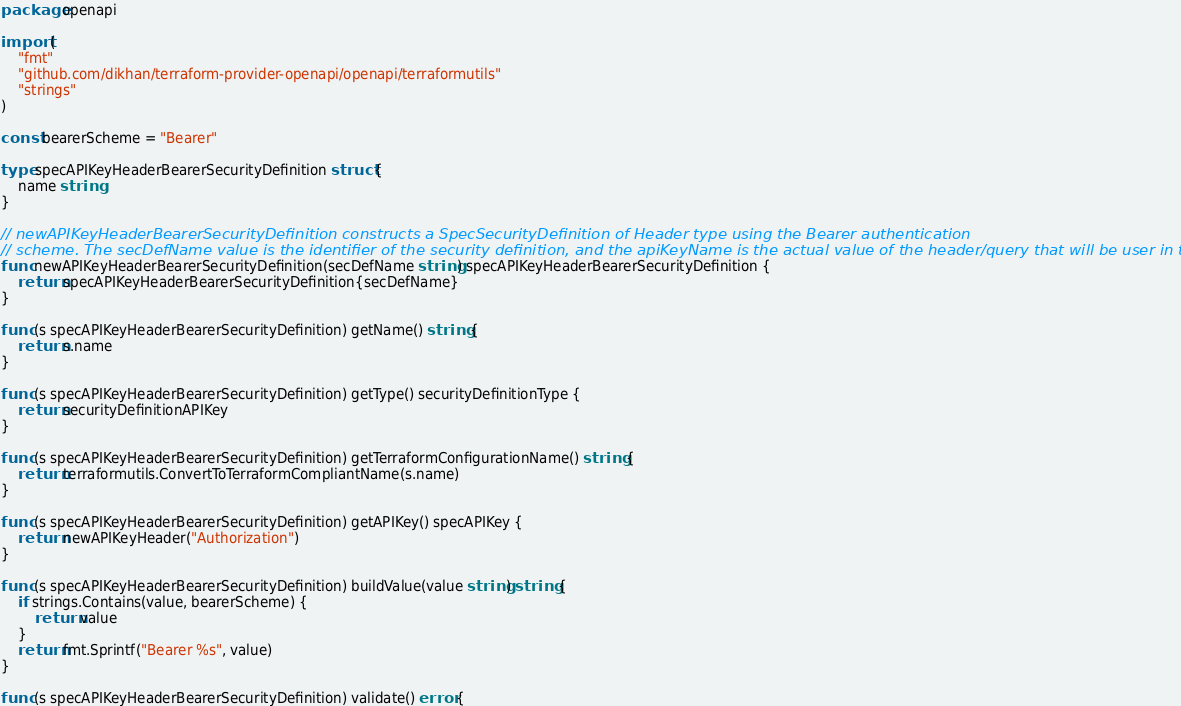Convert code to text. <code><loc_0><loc_0><loc_500><loc_500><_Go_>package openapi

import (
	"fmt"
	"github.com/dikhan/terraform-provider-openapi/openapi/terraformutils"
	"strings"
)

const bearerScheme = "Bearer"

type specAPIKeyHeaderBearerSecurityDefinition struct {
	name string
}

// newAPIKeyHeaderBearerSecurityDefinition constructs a SpecSecurityDefinition of Header type using the Bearer authentication
// scheme. The secDefName value is the identifier of the security definition, and the apiKeyName is the actual value of the header/query that will be user in the HTTP request.
func newAPIKeyHeaderBearerSecurityDefinition(secDefName string) specAPIKeyHeaderBearerSecurityDefinition {
	return specAPIKeyHeaderBearerSecurityDefinition{secDefName}
}

func (s specAPIKeyHeaderBearerSecurityDefinition) getName() string {
	return s.name
}

func (s specAPIKeyHeaderBearerSecurityDefinition) getType() securityDefinitionType {
	return securityDefinitionAPIKey
}

func (s specAPIKeyHeaderBearerSecurityDefinition) getTerraformConfigurationName() string {
	return terraformutils.ConvertToTerraformCompliantName(s.name)
}

func (s specAPIKeyHeaderBearerSecurityDefinition) getAPIKey() specAPIKey {
	return newAPIKeyHeader("Authorization")
}

func (s specAPIKeyHeaderBearerSecurityDefinition) buildValue(value string) string {
	if strings.Contains(value, bearerScheme) {
		return value
	}
	return fmt.Sprintf("Bearer %s", value)
}

func (s specAPIKeyHeaderBearerSecurityDefinition) validate() error {</code> 